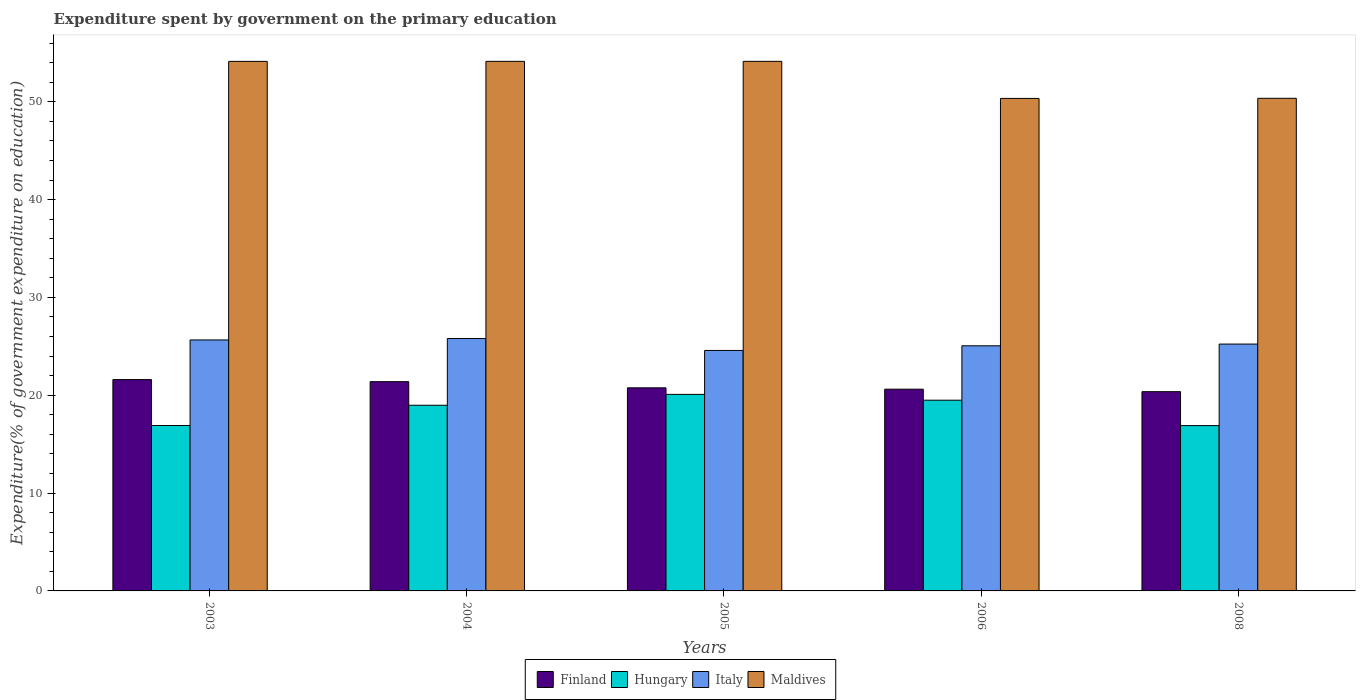Are the number of bars on each tick of the X-axis equal?
Make the answer very short. Yes. How many bars are there on the 3rd tick from the right?
Provide a succinct answer. 4. In how many cases, is the number of bars for a given year not equal to the number of legend labels?
Provide a short and direct response. 0. What is the expenditure spent by government on the primary education in Finland in 2004?
Make the answer very short. 21.39. Across all years, what is the maximum expenditure spent by government on the primary education in Maldives?
Your response must be concise. 54.13. Across all years, what is the minimum expenditure spent by government on the primary education in Finland?
Your answer should be compact. 20.37. In which year was the expenditure spent by government on the primary education in Maldives minimum?
Ensure brevity in your answer.  2006. What is the total expenditure spent by government on the primary education in Maldives in the graph?
Provide a succinct answer. 263.08. What is the difference between the expenditure spent by government on the primary education in Maldives in 2004 and that in 2006?
Offer a very short reply. 3.79. What is the difference between the expenditure spent by government on the primary education in Finland in 2008 and the expenditure spent by government on the primary education in Maldives in 2004?
Your response must be concise. -33.76. What is the average expenditure spent by government on the primary education in Finland per year?
Your answer should be compact. 20.95. In the year 2003, what is the difference between the expenditure spent by government on the primary education in Italy and expenditure spent by government on the primary education in Finland?
Provide a succinct answer. 4.05. In how many years, is the expenditure spent by government on the primary education in Italy greater than 6 %?
Your response must be concise. 5. What is the ratio of the expenditure spent by government on the primary education in Maldives in 2005 to that in 2006?
Your response must be concise. 1.08. Is the expenditure spent by government on the primary education in Maldives in 2003 less than that in 2005?
Make the answer very short. Yes. What is the difference between the highest and the second highest expenditure spent by government on the primary education in Finland?
Your answer should be very brief. 0.21. What is the difference between the highest and the lowest expenditure spent by government on the primary education in Italy?
Offer a terse response. 1.22. Is it the case that in every year, the sum of the expenditure spent by government on the primary education in Italy and expenditure spent by government on the primary education in Hungary is greater than the sum of expenditure spent by government on the primary education in Finland and expenditure spent by government on the primary education in Maldives?
Provide a succinct answer. No. Are all the bars in the graph horizontal?
Your answer should be compact. No. Are the values on the major ticks of Y-axis written in scientific E-notation?
Provide a succinct answer. No. Does the graph contain any zero values?
Ensure brevity in your answer.  No. Does the graph contain grids?
Offer a very short reply. No. How many legend labels are there?
Give a very brief answer. 4. What is the title of the graph?
Make the answer very short. Expenditure spent by government on the primary education. Does "Spain" appear as one of the legend labels in the graph?
Give a very brief answer. No. What is the label or title of the X-axis?
Your response must be concise. Years. What is the label or title of the Y-axis?
Provide a succinct answer. Expenditure(% of government expenditure on education). What is the Expenditure(% of government expenditure on education) in Finland in 2003?
Your response must be concise. 21.6. What is the Expenditure(% of government expenditure on education) of Hungary in 2003?
Offer a terse response. 16.91. What is the Expenditure(% of government expenditure on education) of Italy in 2003?
Give a very brief answer. 25.65. What is the Expenditure(% of government expenditure on education) in Maldives in 2003?
Your answer should be compact. 54.13. What is the Expenditure(% of government expenditure on education) of Finland in 2004?
Give a very brief answer. 21.39. What is the Expenditure(% of government expenditure on education) of Hungary in 2004?
Offer a terse response. 18.98. What is the Expenditure(% of government expenditure on education) in Italy in 2004?
Your answer should be compact. 25.8. What is the Expenditure(% of government expenditure on education) of Maldives in 2004?
Your answer should be very brief. 54.13. What is the Expenditure(% of government expenditure on education) in Finland in 2005?
Your answer should be compact. 20.76. What is the Expenditure(% of government expenditure on education) in Hungary in 2005?
Your answer should be compact. 20.09. What is the Expenditure(% of government expenditure on education) of Italy in 2005?
Provide a succinct answer. 24.58. What is the Expenditure(% of government expenditure on education) in Maldives in 2005?
Provide a succinct answer. 54.13. What is the Expenditure(% of government expenditure on education) of Finland in 2006?
Give a very brief answer. 20.62. What is the Expenditure(% of government expenditure on education) in Hungary in 2006?
Keep it short and to the point. 19.5. What is the Expenditure(% of government expenditure on education) of Italy in 2006?
Your answer should be very brief. 25.06. What is the Expenditure(% of government expenditure on education) of Maldives in 2006?
Offer a terse response. 50.34. What is the Expenditure(% of government expenditure on education) of Finland in 2008?
Ensure brevity in your answer.  20.37. What is the Expenditure(% of government expenditure on education) in Hungary in 2008?
Offer a very short reply. 16.9. What is the Expenditure(% of government expenditure on education) of Italy in 2008?
Keep it short and to the point. 25.23. What is the Expenditure(% of government expenditure on education) of Maldives in 2008?
Offer a terse response. 50.35. Across all years, what is the maximum Expenditure(% of government expenditure on education) of Finland?
Your answer should be compact. 21.6. Across all years, what is the maximum Expenditure(% of government expenditure on education) in Hungary?
Your answer should be very brief. 20.09. Across all years, what is the maximum Expenditure(% of government expenditure on education) in Italy?
Give a very brief answer. 25.8. Across all years, what is the maximum Expenditure(% of government expenditure on education) in Maldives?
Provide a short and direct response. 54.13. Across all years, what is the minimum Expenditure(% of government expenditure on education) in Finland?
Your answer should be compact. 20.37. Across all years, what is the minimum Expenditure(% of government expenditure on education) of Hungary?
Your answer should be very brief. 16.9. Across all years, what is the minimum Expenditure(% of government expenditure on education) in Italy?
Give a very brief answer. 24.58. Across all years, what is the minimum Expenditure(% of government expenditure on education) of Maldives?
Your answer should be compact. 50.34. What is the total Expenditure(% of government expenditure on education) of Finland in the graph?
Your response must be concise. 104.74. What is the total Expenditure(% of government expenditure on education) in Hungary in the graph?
Make the answer very short. 92.37. What is the total Expenditure(% of government expenditure on education) of Italy in the graph?
Your response must be concise. 126.32. What is the total Expenditure(% of government expenditure on education) in Maldives in the graph?
Your answer should be compact. 263.08. What is the difference between the Expenditure(% of government expenditure on education) of Finland in 2003 and that in 2004?
Provide a short and direct response. 0.21. What is the difference between the Expenditure(% of government expenditure on education) in Hungary in 2003 and that in 2004?
Provide a short and direct response. -2.07. What is the difference between the Expenditure(% of government expenditure on education) in Italy in 2003 and that in 2004?
Provide a succinct answer. -0.15. What is the difference between the Expenditure(% of government expenditure on education) of Maldives in 2003 and that in 2004?
Provide a succinct answer. -0. What is the difference between the Expenditure(% of government expenditure on education) of Finland in 2003 and that in 2005?
Your answer should be compact. 0.84. What is the difference between the Expenditure(% of government expenditure on education) of Hungary in 2003 and that in 2005?
Ensure brevity in your answer.  -3.18. What is the difference between the Expenditure(% of government expenditure on education) of Italy in 2003 and that in 2005?
Give a very brief answer. 1.07. What is the difference between the Expenditure(% of government expenditure on education) in Maldives in 2003 and that in 2005?
Give a very brief answer. -0. What is the difference between the Expenditure(% of government expenditure on education) in Finland in 2003 and that in 2006?
Your response must be concise. 0.98. What is the difference between the Expenditure(% of government expenditure on education) in Hungary in 2003 and that in 2006?
Ensure brevity in your answer.  -2.59. What is the difference between the Expenditure(% of government expenditure on education) in Italy in 2003 and that in 2006?
Ensure brevity in your answer.  0.6. What is the difference between the Expenditure(% of government expenditure on education) in Maldives in 2003 and that in 2006?
Your answer should be very brief. 3.79. What is the difference between the Expenditure(% of government expenditure on education) of Finland in 2003 and that in 2008?
Ensure brevity in your answer.  1.23. What is the difference between the Expenditure(% of government expenditure on education) of Hungary in 2003 and that in 2008?
Your response must be concise. 0.01. What is the difference between the Expenditure(% of government expenditure on education) in Italy in 2003 and that in 2008?
Your answer should be very brief. 0.42. What is the difference between the Expenditure(% of government expenditure on education) of Maldives in 2003 and that in 2008?
Your answer should be very brief. 3.78. What is the difference between the Expenditure(% of government expenditure on education) in Finland in 2004 and that in 2005?
Keep it short and to the point. 0.63. What is the difference between the Expenditure(% of government expenditure on education) of Hungary in 2004 and that in 2005?
Ensure brevity in your answer.  -1.11. What is the difference between the Expenditure(% of government expenditure on education) in Italy in 2004 and that in 2005?
Give a very brief answer. 1.22. What is the difference between the Expenditure(% of government expenditure on education) in Maldives in 2004 and that in 2005?
Offer a very short reply. -0. What is the difference between the Expenditure(% of government expenditure on education) in Finland in 2004 and that in 2006?
Provide a succinct answer. 0.77. What is the difference between the Expenditure(% of government expenditure on education) in Hungary in 2004 and that in 2006?
Make the answer very short. -0.52. What is the difference between the Expenditure(% of government expenditure on education) of Italy in 2004 and that in 2006?
Provide a succinct answer. 0.74. What is the difference between the Expenditure(% of government expenditure on education) in Maldives in 2004 and that in 2006?
Provide a short and direct response. 3.79. What is the difference between the Expenditure(% of government expenditure on education) of Finland in 2004 and that in 2008?
Offer a very short reply. 1.02. What is the difference between the Expenditure(% of government expenditure on education) in Hungary in 2004 and that in 2008?
Keep it short and to the point. 2.08. What is the difference between the Expenditure(% of government expenditure on education) of Italy in 2004 and that in 2008?
Ensure brevity in your answer.  0.57. What is the difference between the Expenditure(% of government expenditure on education) in Maldives in 2004 and that in 2008?
Make the answer very short. 3.78. What is the difference between the Expenditure(% of government expenditure on education) of Finland in 2005 and that in 2006?
Offer a very short reply. 0.14. What is the difference between the Expenditure(% of government expenditure on education) in Hungary in 2005 and that in 2006?
Your response must be concise. 0.59. What is the difference between the Expenditure(% of government expenditure on education) in Italy in 2005 and that in 2006?
Your answer should be very brief. -0.48. What is the difference between the Expenditure(% of government expenditure on education) in Maldives in 2005 and that in 2006?
Your answer should be compact. 3.79. What is the difference between the Expenditure(% of government expenditure on education) in Finland in 2005 and that in 2008?
Your answer should be very brief. 0.39. What is the difference between the Expenditure(% of government expenditure on education) of Hungary in 2005 and that in 2008?
Make the answer very short. 3.19. What is the difference between the Expenditure(% of government expenditure on education) in Italy in 2005 and that in 2008?
Offer a terse response. -0.65. What is the difference between the Expenditure(% of government expenditure on education) in Maldives in 2005 and that in 2008?
Provide a short and direct response. 3.78. What is the difference between the Expenditure(% of government expenditure on education) of Finland in 2006 and that in 2008?
Your answer should be compact. 0.25. What is the difference between the Expenditure(% of government expenditure on education) in Hungary in 2006 and that in 2008?
Provide a succinct answer. 2.6. What is the difference between the Expenditure(% of government expenditure on education) in Italy in 2006 and that in 2008?
Your answer should be compact. -0.18. What is the difference between the Expenditure(% of government expenditure on education) in Maldives in 2006 and that in 2008?
Offer a terse response. -0.01. What is the difference between the Expenditure(% of government expenditure on education) of Finland in 2003 and the Expenditure(% of government expenditure on education) of Hungary in 2004?
Provide a short and direct response. 2.62. What is the difference between the Expenditure(% of government expenditure on education) in Finland in 2003 and the Expenditure(% of government expenditure on education) in Italy in 2004?
Offer a very short reply. -4.2. What is the difference between the Expenditure(% of government expenditure on education) of Finland in 2003 and the Expenditure(% of government expenditure on education) of Maldives in 2004?
Your response must be concise. -32.53. What is the difference between the Expenditure(% of government expenditure on education) in Hungary in 2003 and the Expenditure(% of government expenditure on education) in Italy in 2004?
Ensure brevity in your answer.  -8.89. What is the difference between the Expenditure(% of government expenditure on education) of Hungary in 2003 and the Expenditure(% of government expenditure on education) of Maldives in 2004?
Provide a succinct answer. -37.22. What is the difference between the Expenditure(% of government expenditure on education) in Italy in 2003 and the Expenditure(% of government expenditure on education) in Maldives in 2004?
Ensure brevity in your answer.  -28.48. What is the difference between the Expenditure(% of government expenditure on education) of Finland in 2003 and the Expenditure(% of government expenditure on education) of Hungary in 2005?
Your answer should be compact. 1.51. What is the difference between the Expenditure(% of government expenditure on education) of Finland in 2003 and the Expenditure(% of government expenditure on education) of Italy in 2005?
Your answer should be compact. -2.98. What is the difference between the Expenditure(% of government expenditure on education) of Finland in 2003 and the Expenditure(% of government expenditure on education) of Maldives in 2005?
Make the answer very short. -32.53. What is the difference between the Expenditure(% of government expenditure on education) of Hungary in 2003 and the Expenditure(% of government expenditure on education) of Italy in 2005?
Provide a succinct answer. -7.67. What is the difference between the Expenditure(% of government expenditure on education) in Hungary in 2003 and the Expenditure(% of government expenditure on education) in Maldives in 2005?
Provide a succinct answer. -37.22. What is the difference between the Expenditure(% of government expenditure on education) in Italy in 2003 and the Expenditure(% of government expenditure on education) in Maldives in 2005?
Provide a short and direct response. -28.48. What is the difference between the Expenditure(% of government expenditure on education) of Finland in 2003 and the Expenditure(% of government expenditure on education) of Hungary in 2006?
Give a very brief answer. 2.11. What is the difference between the Expenditure(% of government expenditure on education) in Finland in 2003 and the Expenditure(% of government expenditure on education) in Italy in 2006?
Provide a short and direct response. -3.45. What is the difference between the Expenditure(% of government expenditure on education) in Finland in 2003 and the Expenditure(% of government expenditure on education) in Maldives in 2006?
Keep it short and to the point. -28.74. What is the difference between the Expenditure(% of government expenditure on education) in Hungary in 2003 and the Expenditure(% of government expenditure on education) in Italy in 2006?
Offer a terse response. -8.15. What is the difference between the Expenditure(% of government expenditure on education) in Hungary in 2003 and the Expenditure(% of government expenditure on education) in Maldives in 2006?
Your answer should be compact. -33.43. What is the difference between the Expenditure(% of government expenditure on education) in Italy in 2003 and the Expenditure(% of government expenditure on education) in Maldives in 2006?
Make the answer very short. -24.69. What is the difference between the Expenditure(% of government expenditure on education) of Finland in 2003 and the Expenditure(% of government expenditure on education) of Hungary in 2008?
Your answer should be compact. 4.7. What is the difference between the Expenditure(% of government expenditure on education) of Finland in 2003 and the Expenditure(% of government expenditure on education) of Italy in 2008?
Offer a terse response. -3.63. What is the difference between the Expenditure(% of government expenditure on education) of Finland in 2003 and the Expenditure(% of government expenditure on education) of Maldives in 2008?
Keep it short and to the point. -28.75. What is the difference between the Expenditure(% of government expenditure on education) of Hungary in 2003 and the Expenditure(% of government expenditure on education) of Italy in 2008?
Offer a very short reply. -8.32. What is the difference between the Expenditure(% of government expenditure on education) of Hungary in 2003 and the Expenditure(% of government expenditure on education) of Maldives in 2008?
Your answer should be very brief. -33.44. What is the difference between the Expenditure(% of government expenditure on education) of Italy in 2003 and the Expenditure(% of government expenditure on education) of Maldives in 2008?
Your answer should be compact. -24.7. What is the difference between the Expenditure(% of government expenditure on education) in Finland in 2004 and the Expenditure(% of government expenditure on education) in Hungary in 2005?
Your answer should be compact. 1.3. What is the difference between the Expenditure(% of government expenditure on education) in Finland in 2004 and the Expenditure(% of government expenditure on education) in Italy in 2005?
Your answer should be very brief. -3.19. What is the difference between the Expenditure(% of government expenditure on education) of Finland in 2004 and the Expenditure(% of government expenditure on education) of Maldives in 2005?
Provide a short and direct response. -32.74. What is the difference between the Expenditure(% of government expenditure on education) in Hungary in 2004 and the Expenditure(% of government expenditure on education) in Italy in 2005?
Offer a terse response. -5.6. What is the difference between the Expenditure(% of government expenditure on education) of Hungary in 2004 and the Expenditure(% of government expenditure on education) of Maldives in 2005?
Offer a terse response. -35.15. What is the difference between the Expenditure(% of government expenditure on education) in Italy in 2004 and the Expenditure(% of government expenditure on education) in Maldives in 2005?
Make the answer very short. -28.33. What is the difference between the Expenditure(% of government expenditure on education) in Finland in 2004 and the Expenditure(% of government expenditure on education) in Hungary in 2006?
Offer a very short reply. 1.89. What is the difference between the Expenditure(% of government expenditure on education) in Finland in 2004 and the Expenditure(% of government expenditure on education) in Italy in 2006?
Your answer should be very brief. -3.67. What is the difference between the Expenditure(% of government expenditure on education) in Finland in 2004 and the Expenditure(% of government expenditure on education) in Maldives in 2006?
Offer a terse response. -28.95. What is the difference between the Expenditure(% of government expenditure on education) of Hungary in 2004 and the Expenditure(% of government expenditure on education) of Italy in 2006?
Provide a short and direct response. -6.08. What is the difference between the Expenditure(% of government expenditure on education) of Hungary in 2004 and the Expenditure(% of government expenditure on education) of Maldives in 2006?
Ensure brevity in your answer.  -31.36. What is the difference between the Expenditure(% of government expenditure on education) in Italy in 2004 and the Expenditure(% of government expenditure on education) in Maldives in 2006?
Offer a terse response. -24.54. What is the difference between the Expenditure(% of government expenditure on education) of Finland in 2004 and the Expenditure(% of government expenditure on education) of Hungary in 2008?
Ensure brevity in your answer.  4.49. What is the difference between the Expenditure(% of government expenditure on education) in Finland in 2004 and the Expenditure(% of government expenditure on education) in Italy in 2008?
Give a very brief answer. -3.84. What is the difference between the Expenditure(% of government expenditure on education) of Finland in 2004 and the Expenditure(% of government expenditure on education) of Maldives in 2008?
Provide a succinct answer. -28.96. What is the difference between the Expenditure(% of government expenditure on education) of Hungary in 2004 and the Expenditure(% of government expenditure on education) of Italy in 2008?
Make the answer very short. -6.25. What is the difference between the Expenditure(% of government expenditure on education) in Hungary in 2004 and the Expenditure(% of government expenditure on education) in Maldives in 2008?
Your response must be concise. -31.38. What is the difference between the Expenditure(% of government expenditure on education) in Italy in 2004 and the Expenditure(% of government expenditure on education) in Maldives in 2008?
Make the answer very short. -24.55. What is the difference between the Expenditure(% of government expenditure on education) in Finland in 2005 and the Expenditure(% of government expenditure on education) in Hungary in 2006?
Provide a short and direct response. 1.26. What is the difference between the Expenditure(% of government expenditure on education) in Finland in 2005 and the Expenditure(% of government expenditure on education) in Italy in 2006?
Provide a succinct answer. -4.3. What is the difference between the Expenditure(% of government expenditure on education) of Finland in 2005 and the Expenditure(% of government expenditure on education) of Maldives in 2006?
Provide a short and direct response. -29.58. What is the difference between the Expenditure(% of government expenditure on education) of Hungary in 2005 and the Expenditure(% of government expenditure on education) of Italy in 2006?
Give a very brief answer. -4.97. What is the difference between the Expenditure(% of government expenditure on education) in Hungary in 2005 and the Expenditure(% of government expenditure on education) in Maldives in 2006?
Ensure brevity in your answer.  -30.25. What is the difference between the Expenditure(% of government expenditure on education) in Italy in 2005 and the Expenditure(% of government expenditure on education) in Maldives in 2006?
Your answer should be very brief. -25.76. What is the difference between the Expenditure(% of government expenditure on education) in Finland in 2005 and the Expenditure(% of government expenditure on education) in Hungary in 2008?
Your response must be concise. 3.86. What is the difference between the Expenditure(% of government expenditure on education) of Finland in 2005 and the Expenditure(% of government expenditure on education) of Italy in 2008?
Give a very brief answer. -4.47. What is the difference between the Expenditure(% of government expenditure on education) of Finland in 2005 and the Expenditure(% of government expenditure on education) of Maldives in 2008?
Give a very brief answer. -29.59. What is the difference between the Expenditure(% of government expenditure on education) of Hungary in 2005 and the Expenditure(% of government expenditure on education) of Italy in 2008?
Your response must be concise. -5.14. What is the difference between the Expenditure(% of government expenditure on education) in Hungary in 2005 and the Expenditure(% of government expenditure on education) in Maldives in 2008?
Your response must be concise. -30.26. What is the difference between the Expenditure(% of government expenditure on education) in Italy in 2005 and the Expenditure(% of government expenditure on education) in Maldives in 2008?
Your response must be concise. -25.77. What is the difference between the Expenditure(% of government expenditure on education) of Finland in 2006 and the Expenditure(% of government expenditure on education) of Hungary in 2008?
Your answer should be very brief. 3.72. What is the difference between the Expenditure(% of government expenditure on education) of Finland in 2006 and the Expenditure(% of government expenditure on education) of Italy in 2008?
Provide a succinct answer. -4.61. What is the difference between the Expenditure(% of government expenditure on education) in Finland in 2006 and the Expenditure(% of government expenditure on education) in Maldives in 2008?
Ensure brevity in your answer.  -29.73. What is the difference between the Expenditure(% of government expenditure on education) of Hungary in 2006 and the Expenditure(% of government expenditure on education) of Italy in 2008?
Your answer should be compact. -5.74. What is the difference between the Expenditure(% of government expenditure on education) of Hungary in 2006 and the Expenditure(% of government expenditure on education) of Maldives in 2008?
Your response must be concise. -30.86. What is the difference between the Expenditure(% of government expenditure on education) of Italy in 2006 and the Expenditure(% of government expenditure on education) of Maldives in 2008?
Offer a very short reply. -25.3. What is the average Expenditure(% of government expenditure on education) in Finland per year?
Offer a very short reply. 20.95. What is the average Expenditure(% of government expenditure on education) of Hungary per year?
Your answer should be very brief. 18.47. What is the average Expenditure(% of government expenditure on education) of Italy per year?
Make the answer very short. 25.26. What is the average Expenditure(% of government expenditure on education) of Maldives per year?
Keep it short and to the point. 52.62. In the year 2003, what is the difference between the Expenditure(% of government expenditure on education) in Finland and Expenditure(% of government expenditure on education) in Hungary?
Offer a very short reply. 4.69. In the year 2003, what is the difference between the Expenditure(% of government expenditure on education) of Finland and Expenditure(% of government expenditure on education) of Italy?
Provide a succinct answer. -4.05. In the year 2003, what is the difference between the Expenditure(% of government expenditure on education) in Finland and Expenditure(% of government expenditure on education) in Maldives?
Your response must be concise. -32.53. In the year 2003, what is the difference between the Expenditure(% of government expenditure on education) of Hungary and Expenditure(% of government expenditure on education) of Italy?
Make the answer very short. -8.74. In the year 2003, what is the difference between the Expenditure(% of government expenditure on education) of Hungary and Expenditure(% of government expenditure on education) of Maldives?
Provide a succinct answer. -37.22. In the year 2003, what is the difference between the Expenditure(% of government expenditure on education) of Italy and Expenditure(% of government expenditure on education) of Maldives?
Provide a succinct answer. -28.47. In the year 2004, what is the difference between the Expenditure(% of government expenditure on education) in Finland and Expenditure(% of government expenditure on education) in Hungary?
Offer a terse response. 2.41. In the year 2004, what is the difference between the Expenditure(% of government expenditure on education) in Finland and Expenditure(% of government expenditure on education) in Italy?
Provide a short and direct response. -4.41. In the year 2004, what is the difference between the Expenditure(% of government expenditure on education) in Finland and Expenditure(% of government expenditure on education) in Maldives?
Offer a terse response. -32.74. In the year 2004, what is the difference between the Expenditure(% of government expenditure on education) in Hungary and Expenditure(% of government expenditure on education) in Italy?
Offer a terse response. -6.82. In the year 2004, what is the difference between the Expenditure(% of government expenditure on education) in Hungary and Expenditure(% of government expenditure on education) in Maldives?
Provide a short and direct response. -35.15. In the year 2004, what is the difference between the Expenditure(% of government expenditure on education) in Italy and Expenditure(% of government expenditure on education) in Maldives?
Offer a terse response. -28.33. In the year 2005, what is the difference between the Expenditure(% of government expenditure on education) of Finland and Expenditure(% of government expenditure on education) of Hungary?
Your response must be concise. 0.67. In the year 2005, what is the difference between the Expenditure(% of government expenditure on education) in Finland and Expenditure(% of government expenditure on education) in Italy?
Make the answer very short. -3.82. In the year 2005, what is the difference between the Expenditure(% of government expenditure on education) in Finland and Expenditure(% of government expenditure on education) in Maldives?
Your answer should be compact. -33.37. In the year 2005, what is the difference between the Expenditure(% of government expenditure on education) in Hungary and Expenditure(% of government expenditure on education) in Italy?
Provide a short and direct response. -4.49. In the year 2005, what is the difference between the Expenditure(% of government expenditure on education) in Hungary and Expenditure(% of government expenditure on education) in Maldives?
Keep it short and to the point. -34.04. In the year 2005, what is the difference between the Expenditure(% of government expenditure on education) in Italy and Expenditure(% of government expenditure on education) in Maldives?
Your response must be concise. -29.55. In the year 2006, what is the difference between the Expenditure(% of government expenditure on education) in Finland and Expenditure(% of government expenditure on education) in Hungary?
Offer a very short reply. 1.12. In the year 2006, what is the difference between the Expenditure(% of government expenditure on education) of Finland and Expenditure(% of government expenditure on education) of Italy?
Your answer should be compact. -4.44. In the year 2006, what is the difference between the Expenditure(% of government expenditure on education) of Finland and Expenditure(% of government expenditure on education) of Maldives?
Offer a very short reply. -29.72. In the year 2006, what is the difference between the Expenditure(% of government expenditure on education) of Hungary and Expenditure(% of government expenditure on education) of Italy?
Provide a short and direct response. -5.56. In the year 2006, what is the difference between the Expenditure(% of government expenditure on education) in Hungary and Expenditure(% of government expenditure on education) in Maldives?
Your answer should be compact. -30.85. In the year 2006, what is the difference between the Expenditure(% of government expenditure on education) in Italy and Expenditure(% of government expenditure on education) in Maldives?
Ensure brevity in your answer.  -25.29. In the year 2008, what is the difference between the Expenditure(% of government expenditure on education) of Finland and Expenditure(% of government expenditure on education) of Hungary?
Offer a terse response. 3.47. In the year 2008, what is the difference between the Expenditure(% of government expenditure on education) of Finland and Expenditure(% of government expenditure on education) of Italy?
Keep it short and to the point. -4.86. In the year 2008, what is the difference between the Expenditure(% of government expenditure on education) in Finland and Expenditure(% of government expenditure on education) in Maldives?
Provide a short and direct response. -29.99. In the year 2008, what is the difference between the Expenditure(% of government expenditure on education) in Hungary and Expenditure(% of government expenditure on education) in Italy?
Make the answer very short. -8.33. In the year 2008, what is the difference between the Expenditure(% of government expenditure on education) of Hungary and Expenditure(% of government expenditure on education) of Maldives?
Keep it short and to the point. -33.45. In the year 2008, what is the difference between the Expenditure(% of government expenditure on education) in Italy and Expenditure(% of government expenditure on education) in Maldives?
Your response must be concise. -25.12. What is the ratio of the Expenditure(% of government expenditure on education) in Hungary in 2003 to that in 2004?
Your response must be concise. 0.89. What is the ratio of the Expenditure(% of government expenditure on education) in Italy in 2003 to that in 2004?
Keep it short and to the point. 0.99. What is the ratio of the Expenditure(% of government expenditure on education) of Finland in 2003 to that in 2005?
Your answer should be compact. 1.04. What is the ratio of the Expenditure(% of government expenditure on education) of Hungary in 2003 to that in 2005?
Your answer should be very brief. 0.84. What is the ratio of the Expenditure(% of government expenditure on education) of Italy in 2003 to that in 2005?
Your answer should be compact. 1.04. What is the ratio of the Expenditure(% of government expenditure on education) of Maldives in 2003 to that in 2005?
Offer a terse response. 1. What is the ratio of the Expenditure(% of government expenditure on education) of Finland in 2003 to that in 2006?
Your answer should be compact. 1.05. What is the ratio of the Expenditure(% of government expenditure on education) of Hungary in 2003 to that in 2006?
Provide a short and direct response. 0.87. What is the ratio of the Expenditure(% of government expenditure on education) in Italy in 2003 to that in 2006?
Offer a very short reply. 1.02. What is the ratio of the Expenditure(% of government expenditure on education) of Maldives in 2003 to that in 2006?
Your answer should be very brief. 1.08. What is the ratio of the Expenditure(% of government expenditure on education) in Finland in 2003 to that in 2008?
Your answer should be compact. 1.06. What is the ratio of the Expenditure(% of government expenditure on education) of Italy in 2003 to that in 2008?
Your response must be concise. 1.02. What is the ratio of the Expenditure(% of government expenditure on education) of Maldives in 2003 to that in 2008?
Offer a very short reply. 1.07. What is the ratio of the Expenditure(% of government expenditure on education) in Finland in 2004 to that in 2005?
Make the answer very short. 1.03. What is the ratio of the Expenditure(% of government expenditure on education) in Hungary in 2004 to that in 2005?
Keep it short and to the point. 0.94. What is the ratio of the Expenditure(% of government expenditure on education) in Italy in 2004 to that in 2005?
Your answer should be very brief. 1.05. What is the ratio of the Expenditure(% of government expenditure on education) in Finland in 2004 to that in 2006?
Offer a very short reply. 1.04. What is the ratio of the Expenditure(% of government expenditure on education) of Hungary in 2004 to that in 2006?
Give a very brief answer. 0.97. What is the ratio of the Expenditure(% of government expenditure on education) in Italy in 2004 to that in 2006?
Offer a very short reply. 1.03. What is the ratio of the Expenditure(% of government expenditure on education) of Maldives in 2004 to that in 2006?
Keep it short and to the point. 1.08. What is the ratio of the Expenditure(% of government expenditure on education) in Finland in 2004 to that in 2008?
Provide a succinct answer. 1.05. What is the ratio of the Expenditure(% of government expenditure on education) of Hungary in 2004 to that in 2008?
Make the answer very short. 1.12. What is the ratio of the Expenditure(% of government expenditure on education) in Italy in 2004 to that in 2008?
Make the answer very short. 1.02. What is the ratio of the Expenditure(% of government expenditure on education) in Maldives in 2004 to that in 2008?
Give a very brief answer. 1.07. What is the ratio of the Expenditure(% of government expenditure on education) of Finland in 2005 to that in 2006?
Offer a terse response. 1.01. What is the ratio of the Expenditure(% of government expenditure on education) in Hungary in 2005 to that in 2006?
Offer a very short reply. 1.03. What is the ratio of the Expenditure(% of government expenditure on education) in Italy in 2005 to that in 2006?
Your answer should be compact. 0.98. What is the ratio of the Expenditure(% of government expenditure on education) of Maldives in 2005 to that in 2006?
Offer a very short reply. 1.08. What is the ratio of the Expenditure(% of government expenditure on education) in Finland in 2005 to that in 2008?
Offer a terse response. 1.02. What is the ratio of the Expenditure(% of government expenditure on education) in Hungary in 2005 to that in 2008?
Offer a very short reply. 1.19. What is the ratio of the Expenditure(% of government expenditure on education) of Italy in 2005 to that in 2008?
Offer a terse response. 0.97. What is the ratio of the Expenditure(% of government expenditure on education) of Maldives in 2005 to that in 2008?
Give a very brief answer. 1.07. What is the ratio of the Expenditure(% of government expenditure on education) in Finland in 2006 to that in 2008?
Your answer should be very brief. 1.01. What is the ratio of the Expenditure(% of government expenditure on education) of Hungary in 2006 to that in 2008?
Ensure brevity in your answer.  1.15. What is the ratio of the Expenditure(% of government expenditure on education) in Italy in 2006 to that in 2008?
Your response must be concise. 0.99. What is the difference between the highest and the second highest Expenditure(% of government expenditure on education) in Finland?
Ensure brevity in your answer.  0.21. What is the difference between the highest and the second highest Expenditure(% of government expenditure on education) in Hungary?
Keep it short and to the point. 0.59. What is the difference between the highest and the second highest Expenditure(% of government expenditure on education) in Italy?
Provide a short and direct response. 0.15. What is the difference between the highest and the second highest Expenditure(% of government expenditure on education) in Maldives?
Keep it short and to the point. 0. What is the difference between the highest and the lowest Expenditure(% of government expenditure on education) in Finland?
Keep it short and to the point. 1.23. What is the difference between the highest and the lowest Expenditure(% of government expenditure on education) in Hungary?
Your answer should be compact. 3.19. What is the difference between the highest and the lowest Expenditure(% of government expenditure on education) in Italy?
Your answer should be very brief. 1.22. What is the difference between the highest and the lowest Expenditure(% of government expenditure on education) in Maldives?
Your response must be concise. 3.79. 